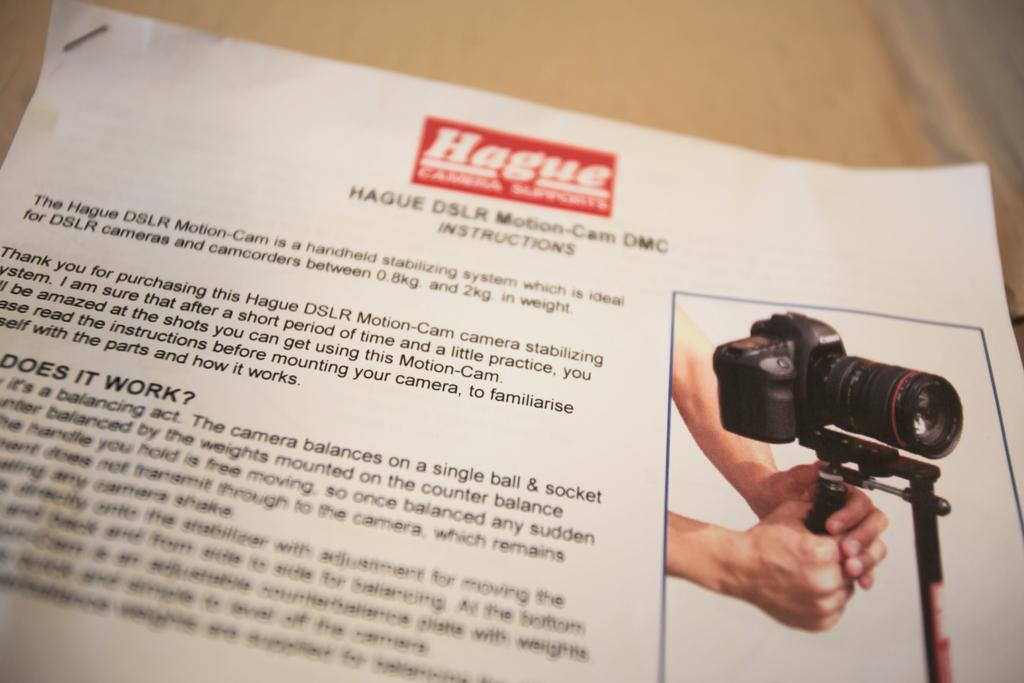What is the medium on which the image is present? The image is on a paper. What can be seen on the right side of the paper? There is an image on the right side of the paper. What activity is the human in the image performing? A human is adjusting a camera in the image. How many passengers are visible in the image? There are no passengers present in the image; it features a human adjusting a camera. What type of curve can be seen in the image? There is no curve present in the image. 